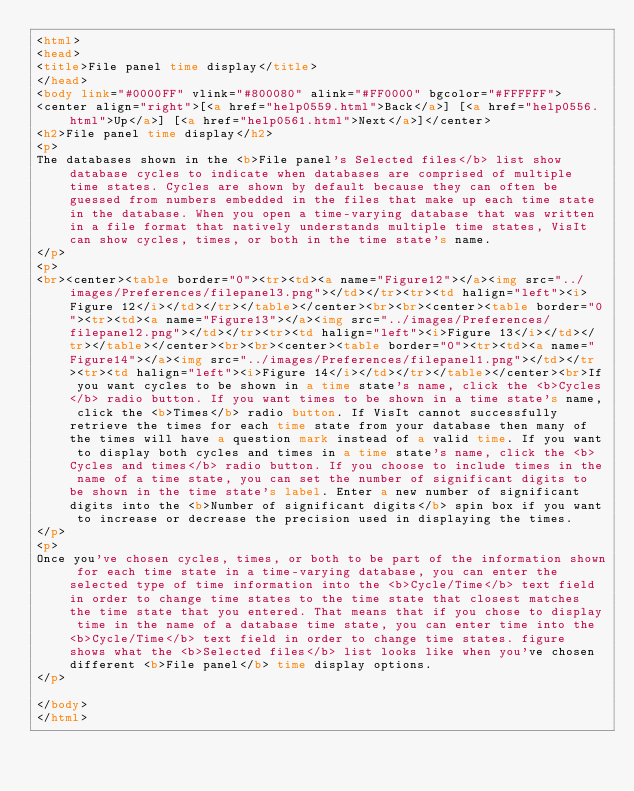Convert code to text. <code><loc_0><loc_0><loc_500><loc_500><_HTML_><html>
<head>
<title>File panel time display</title>
</head>
<body link="#0000FF" vlink="#800080" alink="#FF0000" bgcolor="#FFFFFF">
<center align="right">[<a href="help0559.html">Back</a>] [<a href="help0556.html">Up</a>] [<a href="help0561.html">Next</a>]</center>
<h2>File panel time display</h2>
<p>
The databases shown in the <b>File panel's Selected files</b> list show database cycles to indicate when databases are comprised of multiple time states. Cycles are shown by default because they can often be guessed from numbers embedded in the files that make up each time state in the database. When you open a time-varying database that was written in a file format that natively understands multiple time states, VisIt can show cycles, times, or both in the time state's name.
</p>
<p>
<br><center><table border="0"><tr><td><a name="Figure12"></a><img src="../images/Preferences/filepanel3.png"></td></tr><tr><td halign="left"><i>Figure 12</i></td></tr></table></center><br><br><center><table border="0"><tr><td><a name="Figure13"></a><img src="../images/Preferences/filepanel2.png"></td></tr><tr><td halign="left"><i>Figure 13</i></td></tr></table></center><br><br><center><table border="0"><tr><td><a name="Figure14"></a><img src="../images/Preferences/filepanel1.png"></td></tr><tr><td halign="left"><i>Figure 14</i></td></tr></table></center><br>If you want cycles to be shown in a time state's name, click the <b>Cycles</b> radio button. If you want times to be shown in a time state's name, click the <b>Times</b> radio button. If VisIt cannot successfully retrieve the times for each time state from your database then many of the times will have a question mark instead of a valid time. If you want to display both cycles and times in a time state's name, click the <b>Cycles and times</b> radio button. If you choose to include times in the name of a time state, you can set the number of significant digits to be shown in the time state's label. Enter a new number of significant digits into the <b>Number of significant digits</b> spin box if you want to increase or decrease the precision used in displaying the times. 
</p>
<p>
Once you've chosen cycles, times, or both to be part of the information shown for each time state in a time-varying database, you can enter the selected type of time information into the <b>Cycle/Time</b> text field in order to change time states to the time state that closest matches the time state that you entered. That means that if you chose to display time in the name of a database time state, you can enter time into the <b>Cycle/Time</b> text field in order to change time states. figure shows what the <b>Selected files</b> list looks like when you've chosen different <b>File panel</b> time display options.
</p>

</body>
</html>
</code> 